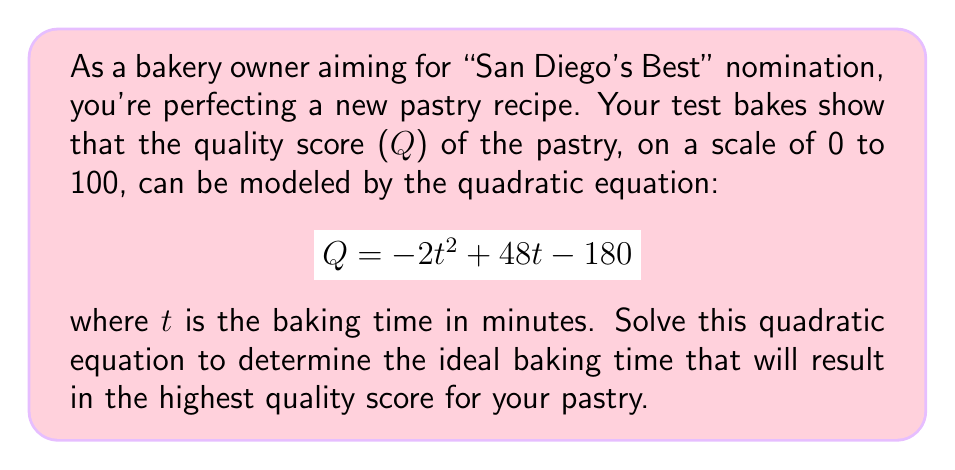What is the answer to this math problem? To find the ideal baking time, we need to find the maximum value of the quadratic function. This occurs at the vertex of the parabola. Let's solve this step-by-step:

1) The quadratic function is in the form $Q = -2t^2 + 48t - 180$, which can be written as $Q = a(t^2) + bt + c$ where $a = -2$, $b = 48$, and $c = -180$.

2) For a quadratic function $f(x) = ax^2 + bx + c$, the x-coordinate of the vertex is given by $x = -\frac{b}{2a}$.

3) In our case, this translates to:

   $t = -\frac{48}{2(-2)} = -\frac{48}{-4} = 12$

4) To verify this is a maximum (not a minimum), we can check that $a$ is negative, which it is ($a = -2$).

5) Therefore, the ideal baking time is 12 minutes.

6) We can calculate the maximum quality score by plugging $t = 12$ into our original equation:

   $Q = -2(12)^2 + 48(12) - 180$
   $= -2(144) + 576 - 180$
   $= -288 + 576 - 180$
   $= 108$

However, since our quality score is on a scale of 0 to 100, we would cap this at 100.
Answer: The ideal baking time for the pastry is 12 minutes, which will result in the highest possible quality score of 100. 